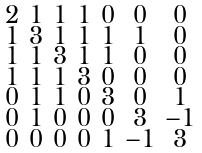Convert formula to latex. <formula><loc_0><loc_0><loc_500><loc_500>\begin{smallmatrix} 2 & 1 & 1 & 1 & 0 & 0 & 0 \\ 1 & 3 & 1 & 1 & 1 & 1 & 0 \\ 1 & 1 & 3 & 1 & 1 & 0 & 0 \\ 1 & 1 & 1 & 3 & 0 & 0 & 0 \\ 0 & 1 & 1 & 0 & 3 & 0 & 1 \\ 0 & 1 & 0 & 0 & 0 & 3 & - 1 \\ 0 & 0 & 0 & 0 & 1 & - 1 & 3 \end{smallmatrix}</formula> 